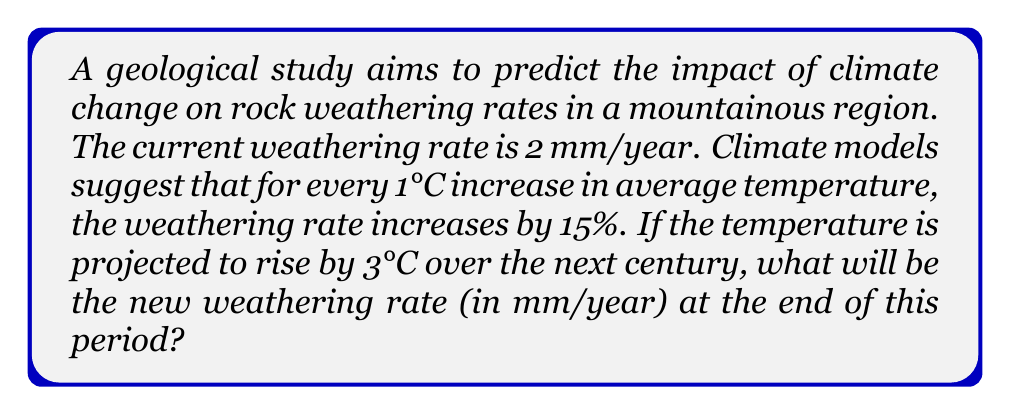What is the answer to this math problem? To solve this problem, we'll follow these steps:

1. Calculate the percentage increase in weathering rate:
   - For each 1°C increase, the rate increases by 15%
   - The temperature is projected to rise by 3°C
   - Total percentage increase = 15% × 3 = 45%

2. Convert the percentage increase to a multiplier:
   - 45% increase = 1 + 0.45 = 1.45

3. Calculate the new weathering rate:
   - Current rate = 2 mm/year
   - New rate = Current rate × Multiplier

Let's put this into mathematical terms:

Let $r$ be the current weathering rate, $t$ be the temperature increase, and $p$ be the percentage increase per degree Celsius.

The new weathering rate $R$ can be expressed as:

$$R = r \cdot (1 + \frac{p \cdot t}{100})$$

Plugging in our values:

$$R = 2 \cdot (1 + \frac{15 \cdot 3}{100})$$
$$R = 2 \cdot (1 + 0.45)$$
$$R = 2 \cdot 1.45$$
$$R = 2.9$$

Therefore, the new weathering rate will be 2.9 mm/year.
Answer: 2.9 mm/year 